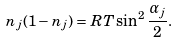<formula> <loc_0><loc_0><loc_500><loc_500>n _ { j } ( 1 - n _ { j } ) = R T \sin ^ { 2 } \frac { \alpha _ { j } } { 2 } .</formula> 